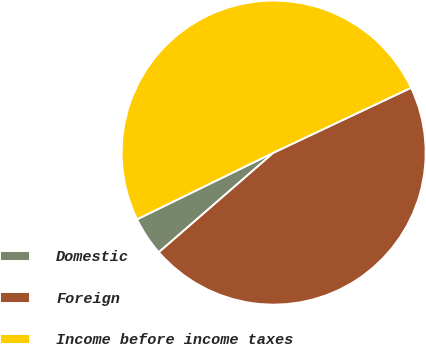Convert chart to OTSL. <chart><loc_0><loc_0><loc_500><loc_500><pie_chart><fcel>Domestic<fcel>Foreign<fcel>Income before income taxes<nl><fcel>4.15%<fcel>45.64%<fcel>50.21%<nl></chart> 